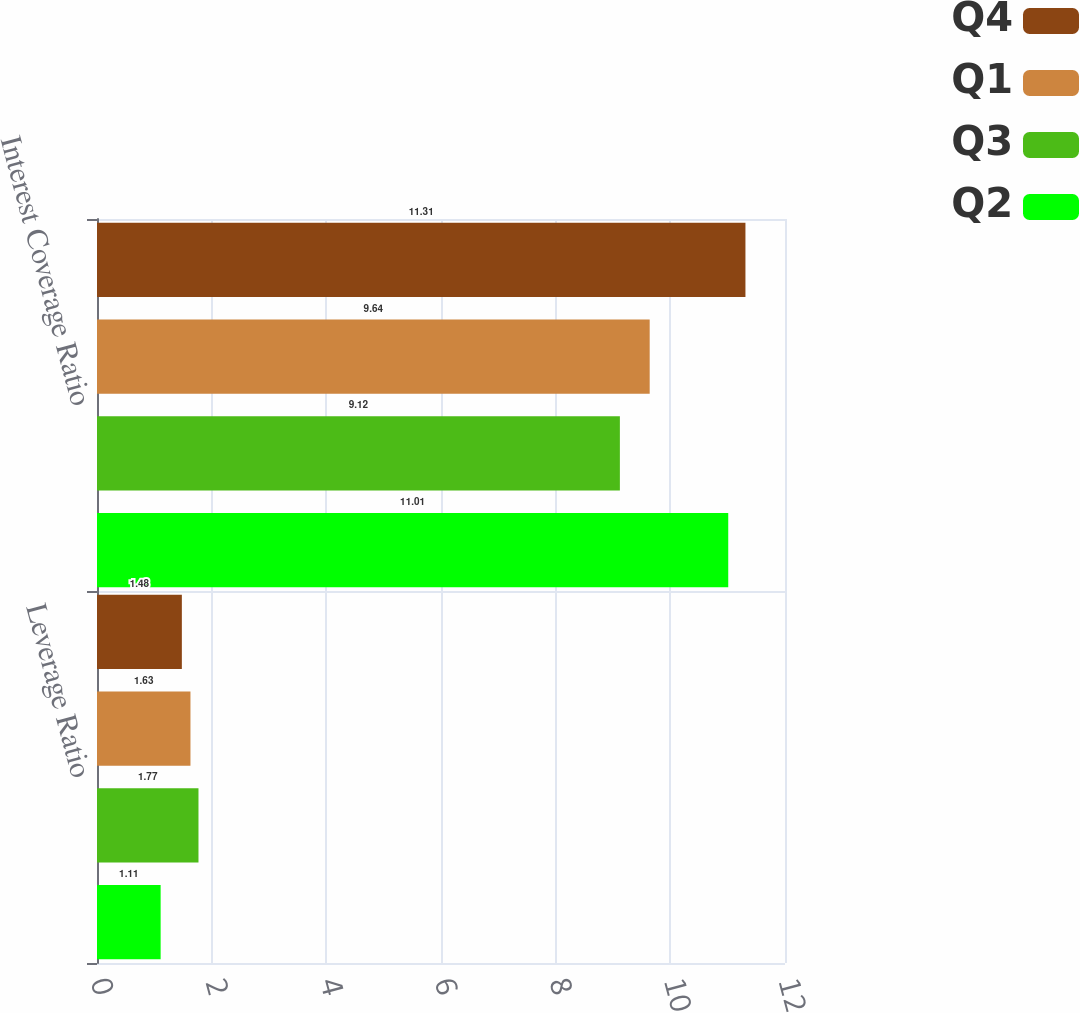Convert chart. <chart><loc_0><loc_0><loc_500><loc_500><stacked_bar_chart><ecel><fcel>Leverage Ratio<fcel>Interest Coverage Ratio<nl><fcel>Q4<fcel>1.48<fcel>11.31<nl><fcel>Q1<fcel>1.63<fcel>9.64<nl><fcel>Q3<fcel>1.77<fcel>9.12<nl><fcel>Q2<fcel>1.11<fcel>11.01<nl></chart> 